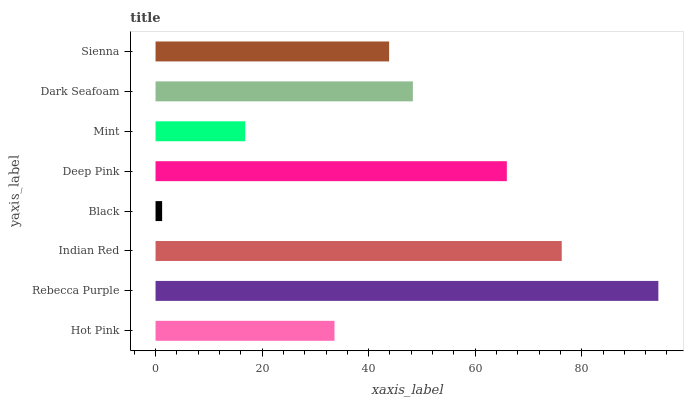Is Black the minimum?
Answer yes or no. Yes. Is Rebecca Purple the maximum?
Answer yes or no. Yes. Is Indian Red the minimum?
Answer yes or no. No. Is Indian Red the maximum?
Answer yes or no. No. Is Rebecca Purple greater than Indian Red?
Answer yes or no. Yes. Is Indian Red less than Rebecca Purple?
Answer yes or no. Yes. Is Indian Red greater than Rebecca Purple?
Answer yes or no. No. Is Rebecca Purple less than Indian Red?
Answer yes or no. No. Is Dark Seafoam the high median?
Answer yes or no. Yes. Is Sienna the low median?
Answer yes or no. Yes. Is Black the high median?
Answer yes or no. No. Is Rebecca Purple the low median?
Answer yes or no. No. 